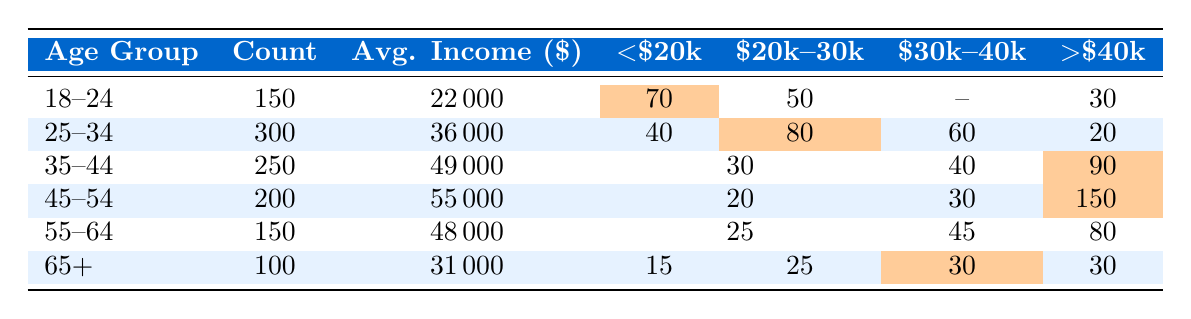What is the average income for single-parent households aged 25-34? The average income for the 25-34 age group is listed as 36,000 in the table.
Answer: 36,000 How many single-parent households are there in the 35-44 age group? The count of single-parent households in the 35-44 age group is shown as 250 in the table.
Answer: 250 What percentage of single-parent households aged 45-54 earn below $30k? In the 45-54 age group, the count of households earning below $30k is 20. The total household count is 200. Thus, the percentage is (20/200) * 100 = 10%.
Answer: 10% Which age group has the highest average income? The table shows that the 45-54 age group has the highest average income at 55,000.
Answer: 45-54 How many single-parent households earn $20k to $30k in the 25-34 age group? The count of households earning between $20k and $30k in the 25-34 age group is 80 as indicated in the table.
Answer: 80 What is the total number of single-parent households across all age groups? To find the total, sum the household counts: 150 + 300 + 250 + 200 + 150 + 100 = 1150.
Answer: 1150 Is it true that there are more households in the 45-54 age group than in the 18-24 age group? The table shows 200 households in the 45-54 age group and 150 in the 18-24 age group, thus it is true that there are more households in the 45-54 age group.
Answer: Yes What is the difference in the number of households earning above $40k between the 35-44 and 45-54 age groups? The 35-44 age group has 90 households earning above $40k, while the 45-54 age group has 90 as well. Therefore, the difference is 90 - 90 = 0.
Answer: 0 How many single-parent households aged 65 and older earn below $20k? According to the table, there are 15 households aged 65 and older earning below $20k.
Answer: 15 What is the cumulative number of households earning below $30k for the 18-24 and 25-34 age groups? In the 18-24 age group, 70 households earn below $20k. In the 25-34 age group, 40 earn below $20k and 80 earn between $20k and $30k, totaling 40 + 80 = 120. Adding 70 from the 18-24 age group results in 70 + 120 = 190.
Answer: 190 